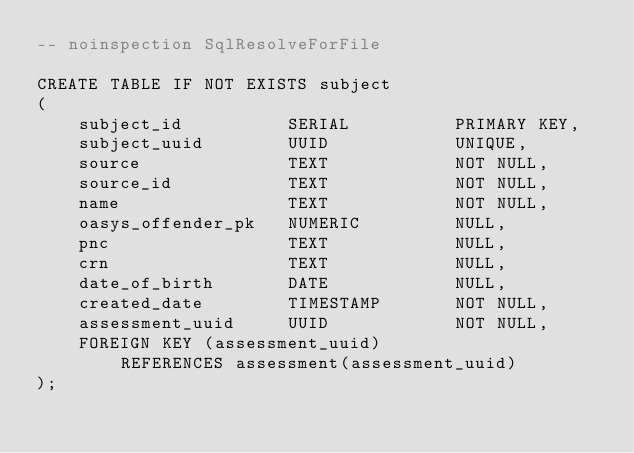Convert code to text. <code><loc_0><loc_0><loc_500><loc_500><_SQL_>-- noinspection SqlResolveForFile

CREATE TABLE IF NOT EXISTS subject
(
    subject_id          SERIAL          PRIMARY KEY,
    subject_uuid        UUID            UNIQUE,
    source              TEXT            NOT NULL,
    source_id           TEXT            NOT NULL,
    name                TEXT            NOT NULL,
    oasys_offender_pk   NUMERIC         NULL,
    pnc                 TEXT            NULL,
    crn                 TEXT            NULL,
    date_of_birth       DATE            NULL,
    created_date        TIMESTAMP       NOT NULL,
    assessment_uuid     UUID            NOT NULL,
    FOREIGN KEY (assessment_uuid)
        REFERENCES assessment(assessment_uuid)
);</code> 